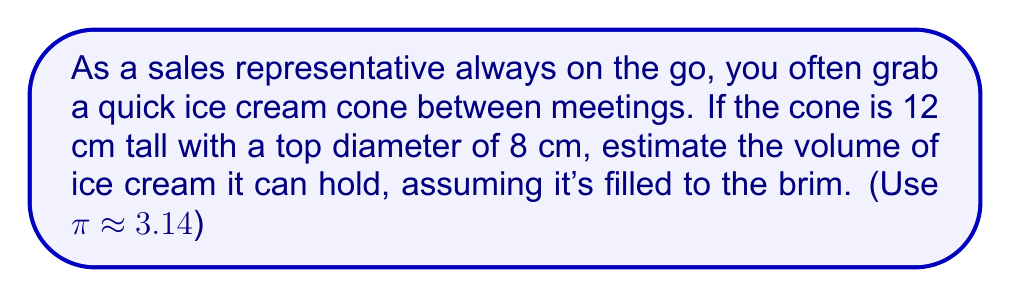Can you answer this question? Let's approach this step-by-step:

1) The shape of an ice cream cone is a cone. The volume of a cone is given by the formula:

   $$V = \frac{1}{3}\pi r^2 h$$

   where $r$ is the radius of the base and $h$ is the height.

2) We're given:
   - Height (h) = 12 cm
   - Diameter at the top = 8 cm

3) We need to find the radius. Since diameter is twice the radius:
   
   $$r = \frac{8}{2} = 4 \text{ cm}$$

4) Now we can substitute these values into our formula:

   $$V = \frac{1}{3} \cdot 3.14 \cdot 4^2 \cdot 12$$

5) Let's calculate:
   
   $$V = \frac{1}{3} \cdot 3.14 \cdot 16 \cdot 12$$
   $$V = \frac{1}{3} \cdot 602.88$$
   $$V = 200.96 \text{ cm}^3$$

6) Rounding to a reasonable estimate:

   $$V \approx 201 \text{ cm}^3$$
Answer: $201 \text{ cm}^3$ 